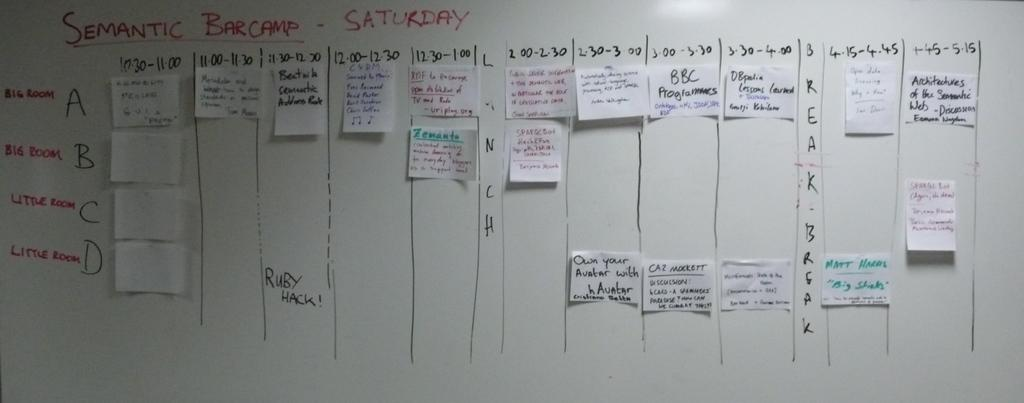<image>
Render a clear and concise summary of the photo. A dry erase board with writings titled Semantic Bar camp 